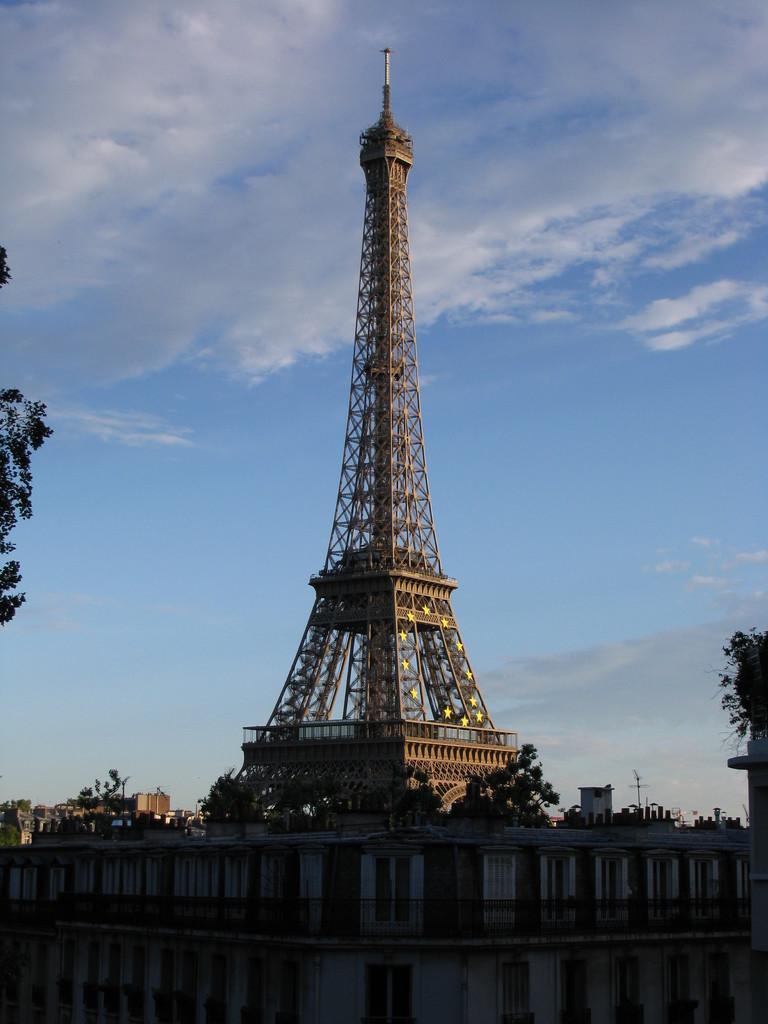Please provide a concise description of this image. In this picture we can see a building, behind we can see a tower, side we can see some trees. 